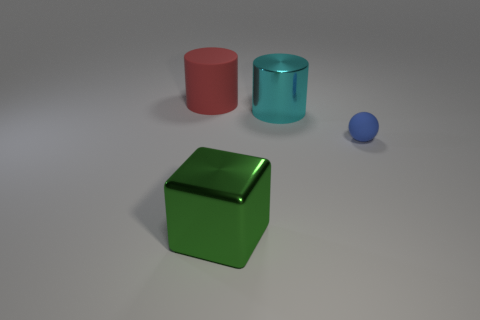Are there any other things that are the same size as the matte sphere?
Give a very brief answer. No. There is a red thing that is the same shape as the big cyan thing; what is it made of?
Keep it short and to the point. Rubber. What number of blue matte objects are the same size as the cyan thing?
Provide a succinct answer. 0. What is the color of the cylinder that is the same material as the ball?
Offer a terse response. Red. Are there fewer big cyan things than tiny green matte balls?
Offer a very short reply. No. How many red things are either large objects or matte cylinders?
Offer a terse response. 1. How many large things are both behind the green thing and on the right side of the large red matte cylinder?
Offer a very short reply. 1. Is the red cylinder made of the same material as the large block?
Make the answer very short. No. There is a red thing that is the same size as the green block; what shape is it?
Keep it short and to the point. Cylinder. Is the number of big red rubber objects greater than the number of small shiny cylinders?
Provide a short and direct response. Yes. 